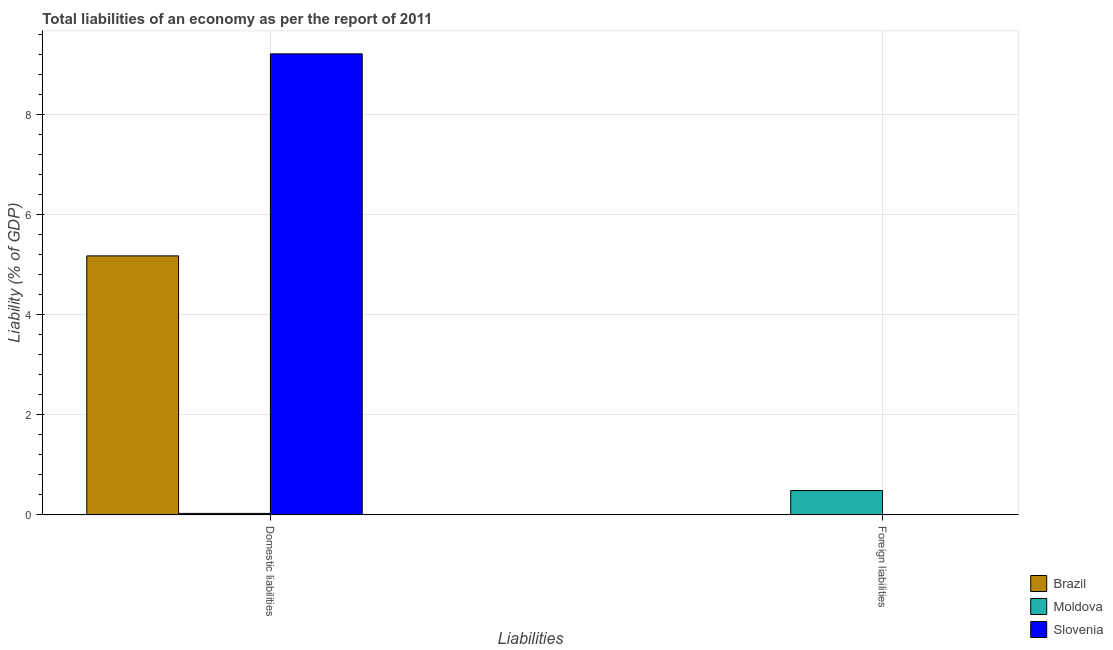How many different coloured bars are there?
Provide a short and direct response. 3. What is the label of the 1st group of bars from the left?
Give a very brief answer. Domestic liabilities. What is the incurrence of domestic liabilities in Moldova?
Provide a succinct answer. 0.03. Across all countries, what is the maximum incurrence of foreign liabilities?
Your answer should be compact. 0.49. Across all countries, what is the minimum incurrence of domestic liabilities?
Provide a succinct answer. 0.03. In which country was the incurrence of foreign liabilities maximum?
Offer a terse response. Moldova. What is the total incurrence of domestic liabilities in the graph?
Make the answer very short. 14.4. What is the difference between the incurrence of domestic liabilities in Brazil and that in Slovenia?
Provide a succinct answer. -4.03. What is the difference between the incurrence of foreign liabilities in Slovenia and the incurrence of domestic liabilities in Moldova?
Provide a succinct answer. -0.03. What is the average incurrence of domestic liabilities per country?
Keep it short and to the point. 4.8. What is the difference between the incurrence of domestic liabilities and incurrence of foreign liabilities in Moldova?
Keep it short and to the point. -0.46. In how many countries, is the incurrence of domestic liabilities greater than 5.6 %?
Your response must be concise. 1. What is the ratio of the incurrence of domestic liabilities in Moldova to that in Slovenia?
Provide a short and direct response. 0. Is the incurrence of domestic liabilities in Moldova less than that in Slovenia?
Your response must be concise. Yes. How many bars are there?
Your answer should be very brief. 4. Are all the bars in the graph horizontal?
Your answer should be compact. No. What is the difference between two consecutive major ticks on the Y-axis?
Your response must be concise. 2. Are the values on the major ticks of Y-axis written in scientific E-notation?
Your answer should be very brief. No. Where does the legend appear in the graph?
Ensure brevity in your answer.  Bottom right. How are the legend labels stacked?
Your response must be concise. Vertical. What is the title of the graph?
Your answer should be very brief. Total liabilities of an economy as per the report of 2011. What is the label or title of the X-axis?
Keep it short and to the point. Liabilities. What is the label or title of the Y-axis?
Provide a short and direct response. Liability (% of GDP). What is the Liability (% of GDP) in Brazil in Domestic liabilities?
Give a very brief answer. 5.17. What is the Liability (% of GDP) of Moldova in Domestic liabilities?
Give a very brief answer. 0.03. What is the Liability (% of GDP) in Slovenia in Domestic liabilities?
Your answer should be very brief. 9.2. What is the Liability (% of GDP) of Moldova in Foreign liabilities?
Offer a very short reply. 0.49. Across all Liabilities, what is the maximum Liability (% of GDP) in Brazil?
Keep it short and to the point. 5.17. Across all Liabilities, what is the maximum Liability (% of GDP) in Moldova?
Offer a very short reply. 0.49. Across all Liabilities, what is the maximum Liability (% of GDP) of Slovenia?
Offer a terse response. 9.2. Across all Liabilities, what is the minimum Liability (% of GDP) of Moldova?
Make the answer very short. 0.03. What is the total Liability (% of GDP) in Brazil in the graph?
Ensure brevity in your answer.  5.17. What is the total Liability (% of GDP) in Moldova in the graph?
Provide a succinct answer. 0.52. What is the total Liability (% of GDP) in Slovenia in the graph?
Ensure brevity in your answer.  9.2. What is the difference between the Liability (% of GDP) of Moldova in Domestic liabilities and that in Foreign liabilities?
Make the answer very short. -0.46. What is the difference between the Liability (% of GDP) of Brazil in Domestic liabilities and the Liability (% of GDP) of Moldova in Foreign liabilities?
Provide a succinct answer. 4.68. What is the average Liability (% of GDP) in Brazil per Liabilities?
Your answer should be compact. 2.59. What is the average Liability (% of GDP) of Moldova per Liabilities?
Provide a short and direct response. 0.26. What is the average Liability (% of GDP) in Slovenia per Liabilities?
Ensure brevity in your answer.  4.6. What is the difference between the Liability (% of GDP) of Brazil and Liability (% of GDP) of Moldova in Domestic liabilities?
Your response must be concise. 5.14. What is the difference between the Liability (% of GDP) in Brazil and Liability (% of GDP) in Slovenia in Domestic liabilities?
Offer a terse response. -4.03. What is the difference between the Liability (% of GDP) in Moldova and Liability (% of GDP) in Slovenia in Domestic liabilities?
Your answer should be very brief. -9.17. What is the ratio of the Liability (% of GDP) of Moldova in Domestic liabilities to that in Foreign liabilities?
Provide a short and direct response. 0.06. What is the difference between the highest and the second highest Liability (% of GDP) in Moldova?
Your response must be concise. 0.46. What is the difference between the highest and the lowest Liability (% of GDP) of Brazil?
Provide a short and direct response. 5.17. What is the difference between the highest and the lowest Liability (% of GDP) in Moldova?
Keep it short and to the point. 0.46. What is the difference between the highest and the lowest Liability (% of GDP) in Slovenia?
Your response must be concise. 9.2. 